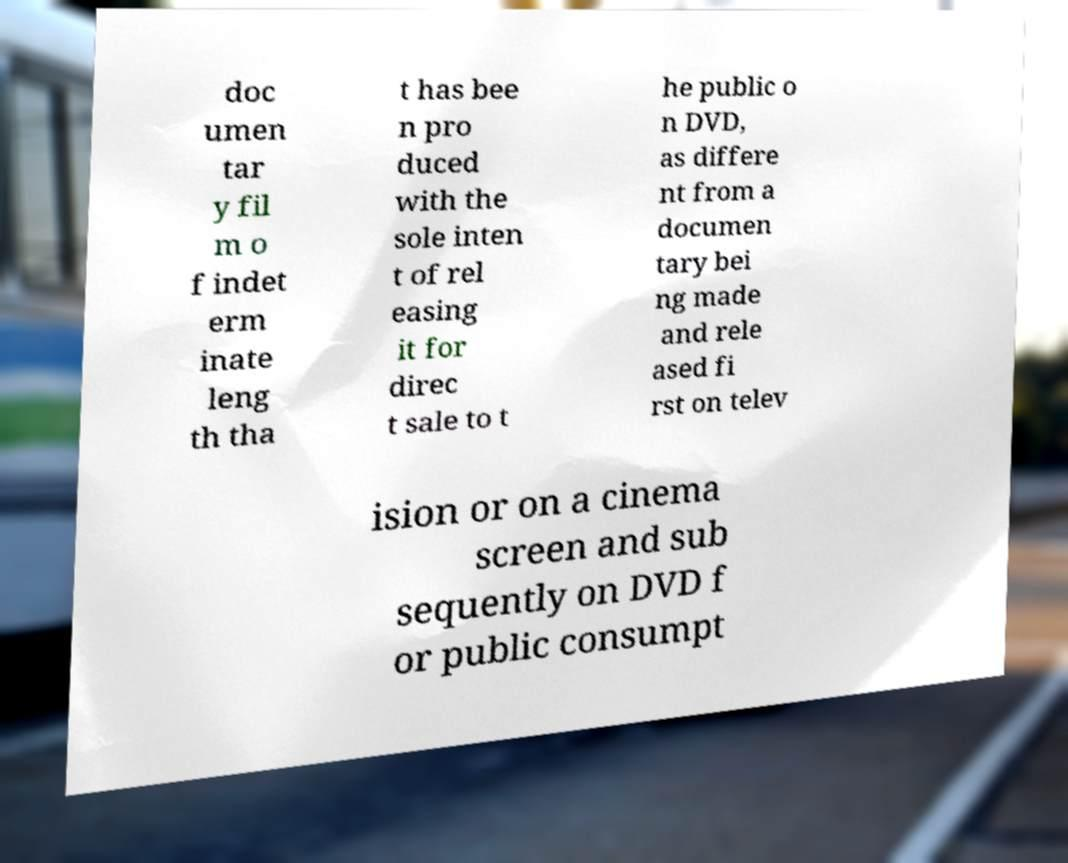What messages or text are displayed in this image? I need them in a readable, typed format. doc umen tar y fil m o f indet erm inate leng th tha t has bee n pro duced with the sole inten t of rel easing it for direc t sale to t he public o n DVD, as differe nt from a documen tary bei ng made and rele ased fi rst on telev ision or on a cinema screen and sub sequently on DVD f or public consumpt 